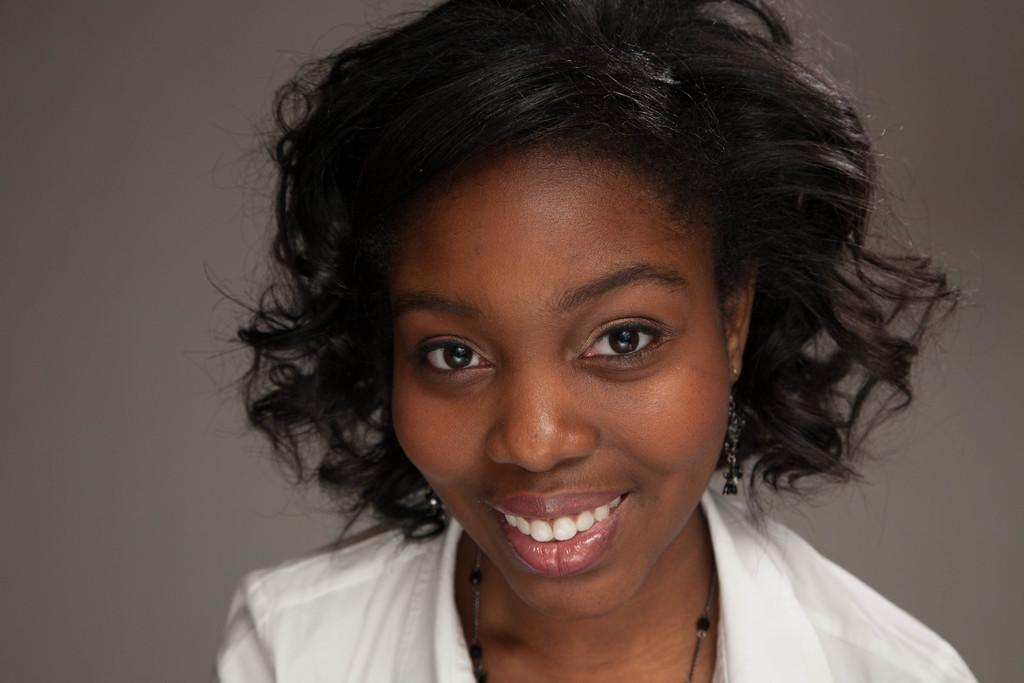Who is the main subject in the image? There is a woman in the image. What is the woman wearing? The woman is wearing a white shirt. What expression does the woman have? The woman is smiling. What color is the background of the image? The background of the image is white. What type of rail can be seen in the image? There is no rail present in the image. Where is the ground visible in the image? The image does not show any ground; it only features the woman and the white background. 